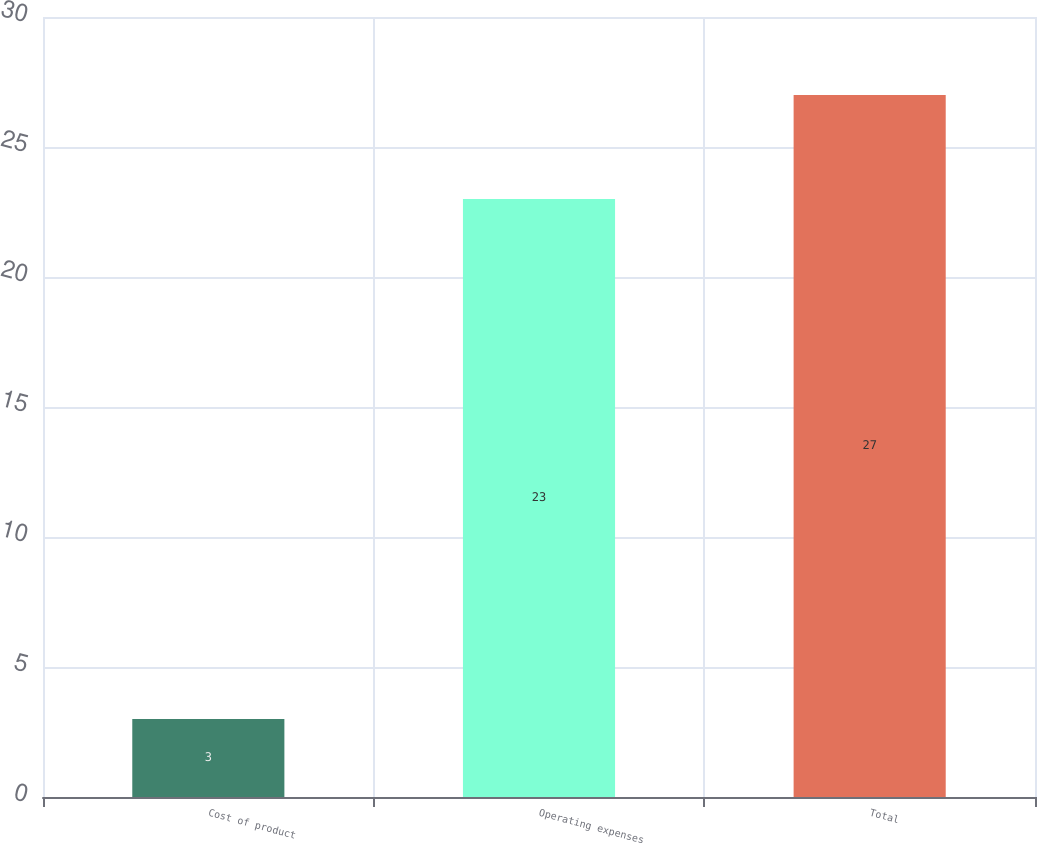<chart> <loc_0><loc_0><loc_500><loc_500><bar_chart><fcel>Cost of product<fcel>Operating expenses<fcel>Total<nl><fcel>3<fcel>23<fcel>27<nl></chart> 